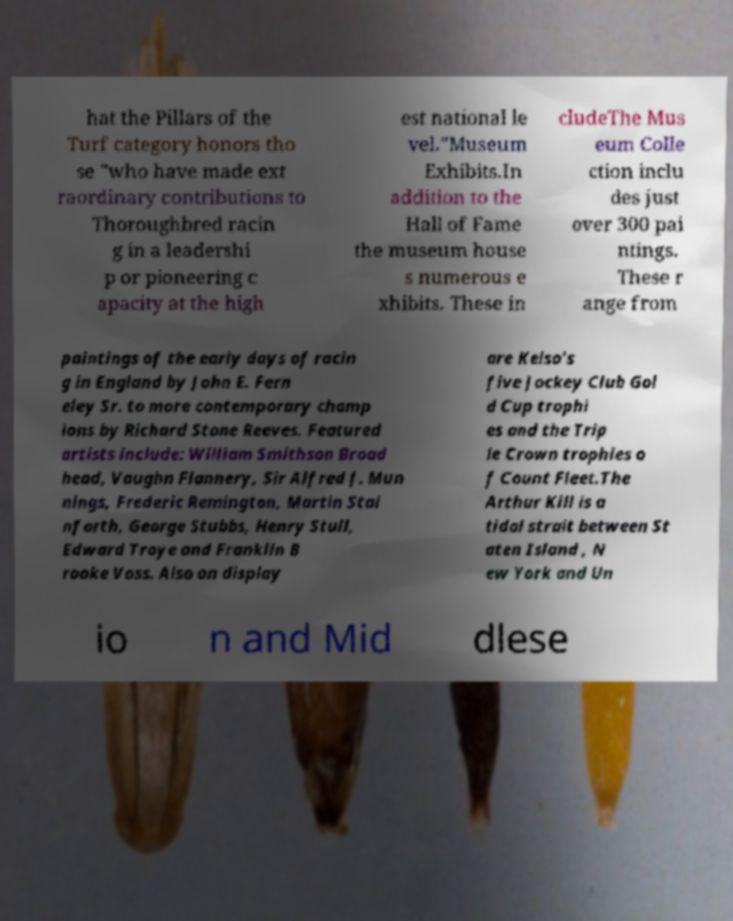Please identify and transcribe the text found in this image. hat the Pillars of the Turf category honors tho se "who have made ext raordinary contributions to Thoroughbred racin g in a leadershi p or pioneering c apacity at the high est national le vel."Museum Exhibits.In addition to the Hall of Fame the museum house s numerous e xhibits. These in cludeThe Mus eum Colle ction inclu des just over 300 pai ntings. These r ange from paintings of the early days of racin g in England by John E. Fern eley Sr. to more contemporary champ ions by Richard Stone Reeves. Featured artists include: William Smithson Broad head, Vaughn Flannery, Sir Alfred J. Mun nings, Frederic Remington, Martin Stai nforth, George Stubbs, Henry Stull, Edward Troye and Franklin B rooke Voss. Also on display are Kelso's five Jockey Club Gol d Cup trophi es and the Trip le Crown trophies o f Count Fleet.The Arthur Kill is a tidal strait between St aten Island , N ew York and Un io n and Mid dlese 